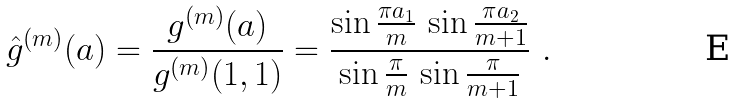<formula> <loc_0><loc_0><loc_500><loc_500>\hat { g } ^ { ( m ) } ( { a } ) = \frac { g ^ { ( m ) } ( { a } ) } { g ^ { ( m ) } ( 1 , 1 ) } = \frac { \sin \frac { \pi a _ { 1 } } { m } \, \sin \frac { \pi a _ { 2 } } { m + 1 } } { \sin \frac { \pi } { m } \, \sin \frac { \pi } { m + 1 } } \ .</formula> 